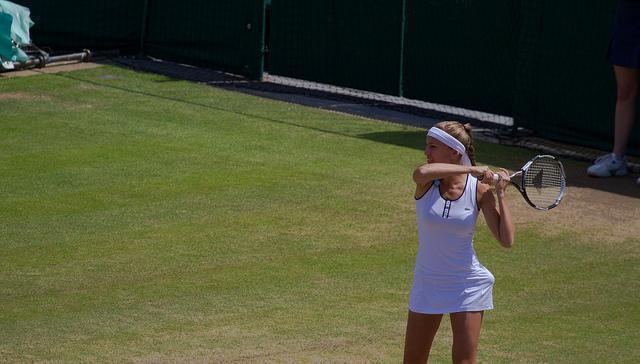How many people can be seen?
Give a very brief answer. 2. How many people are wearing skis in this image?
Give a very brief answer. 0. 